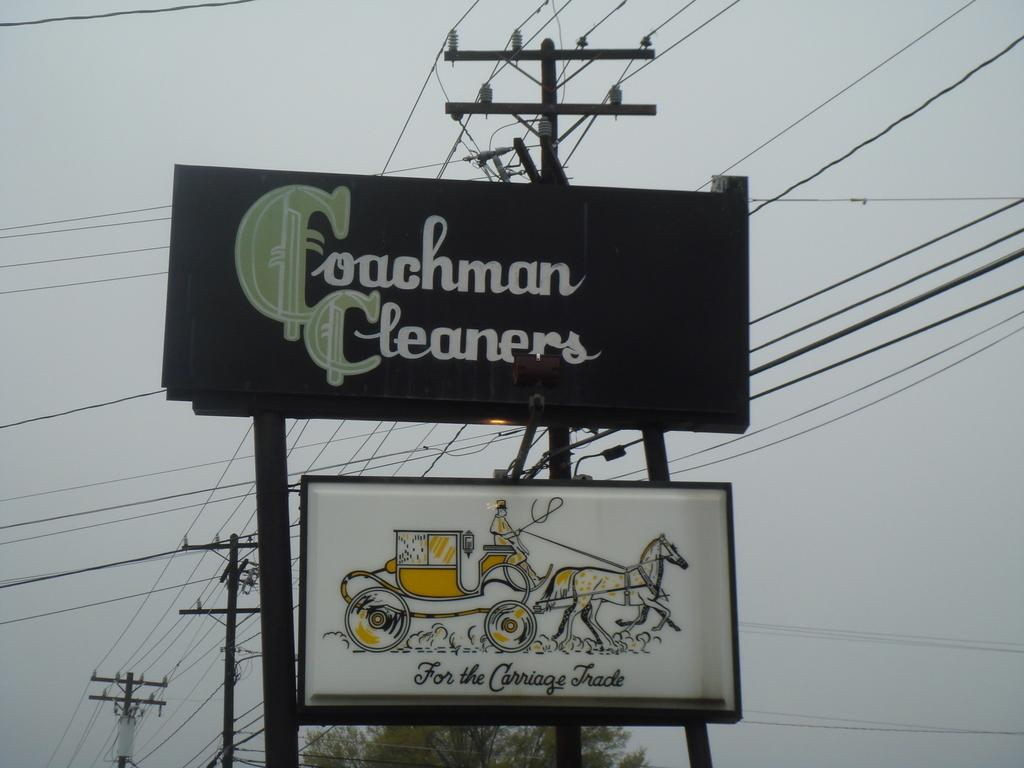<image>
Describe the image concisely. A large black billboard sign for Coachman Cleaners 